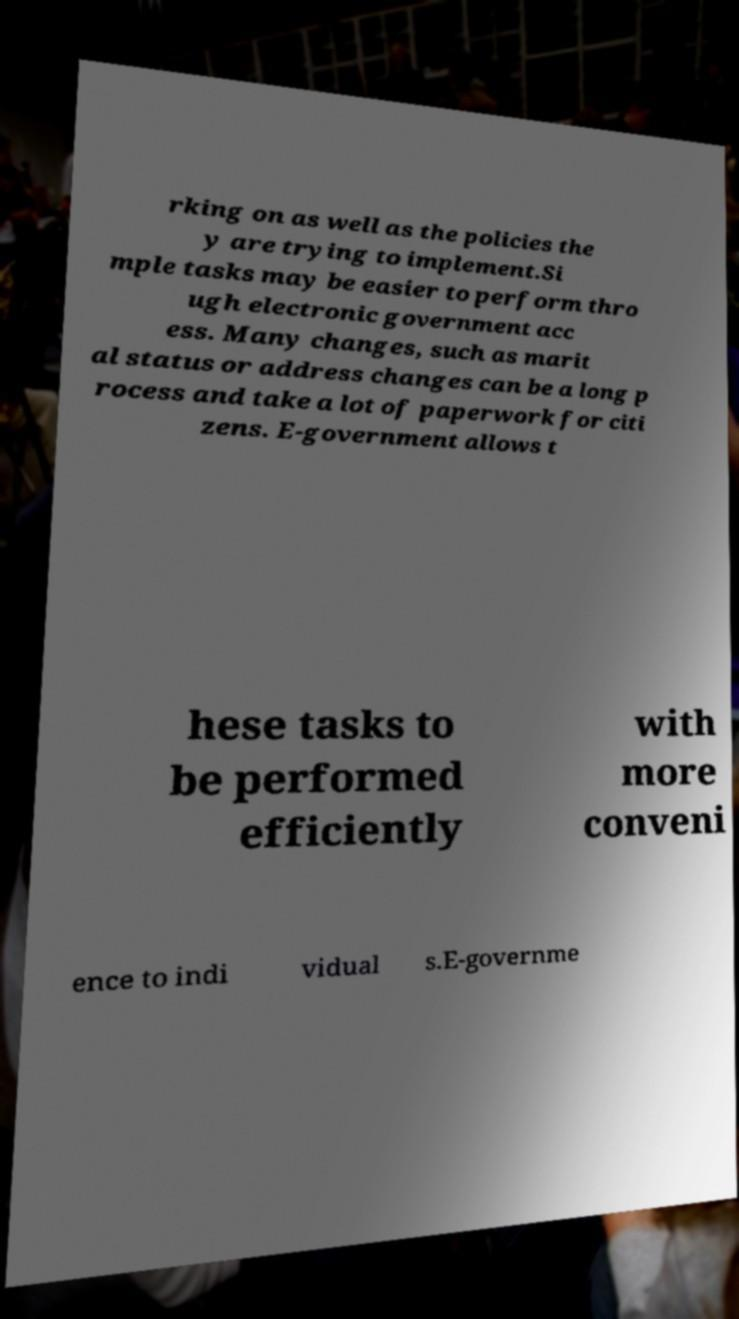Could you extract and type out the text from this image? rking on as well as the policies the y are trying to implement.Si mple tasks may be easier to perform thro ugh electronic government acc ess. Many changes, such as marit al status or address changes can be a long p rocess and take a lot of paperwork for citi zens. E-government allows t hese tasks to be performed efficiently with more conveni ence to indi vidual s.E-governme 